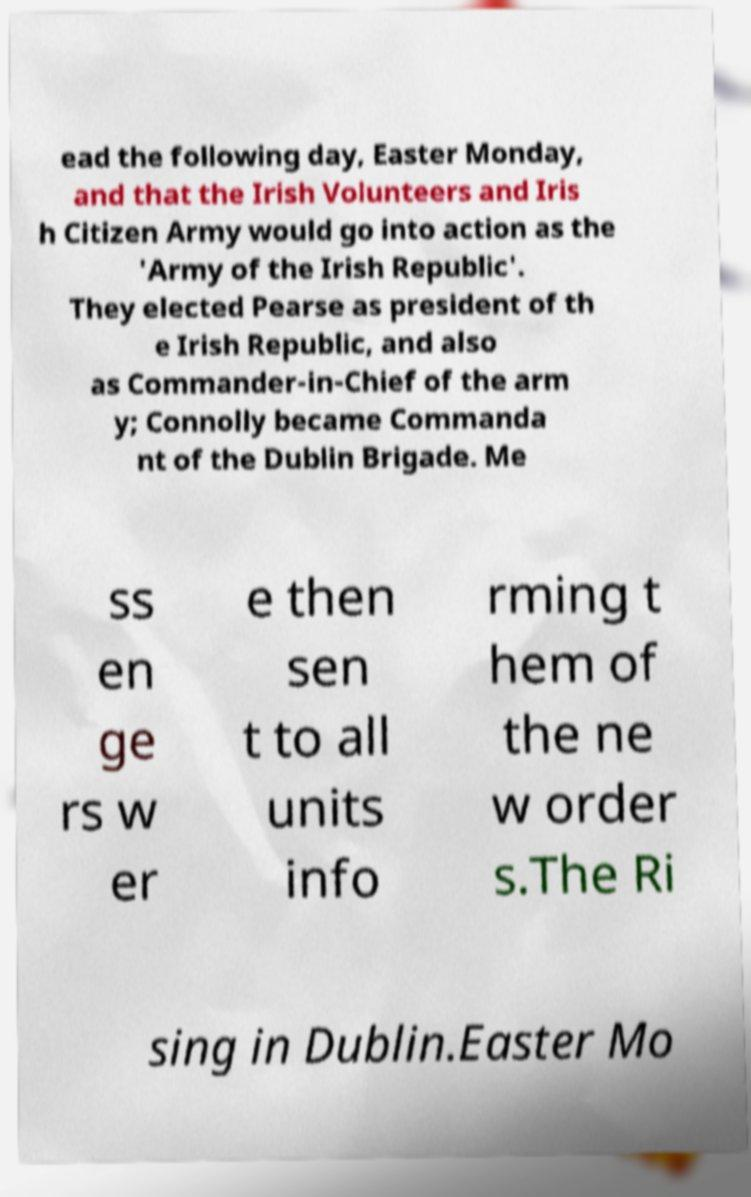Please identify and transcribe the text found in this image. ead the following day, Easter Monday, and that the Irish Volunteers and Iris h Citizen Army would go into action as the 'Army of the Irish Republic'. They elected Pearse as president of th e Irish Republic, and also as Commander-in-Chief of the arm y; Connolly became Commanda nt of the Dublin Brigade. Me ss en ge rs w er e then sen t to all units info rming t hem of the ne w order s.The Ri sing in Dublin.Easter Mo 